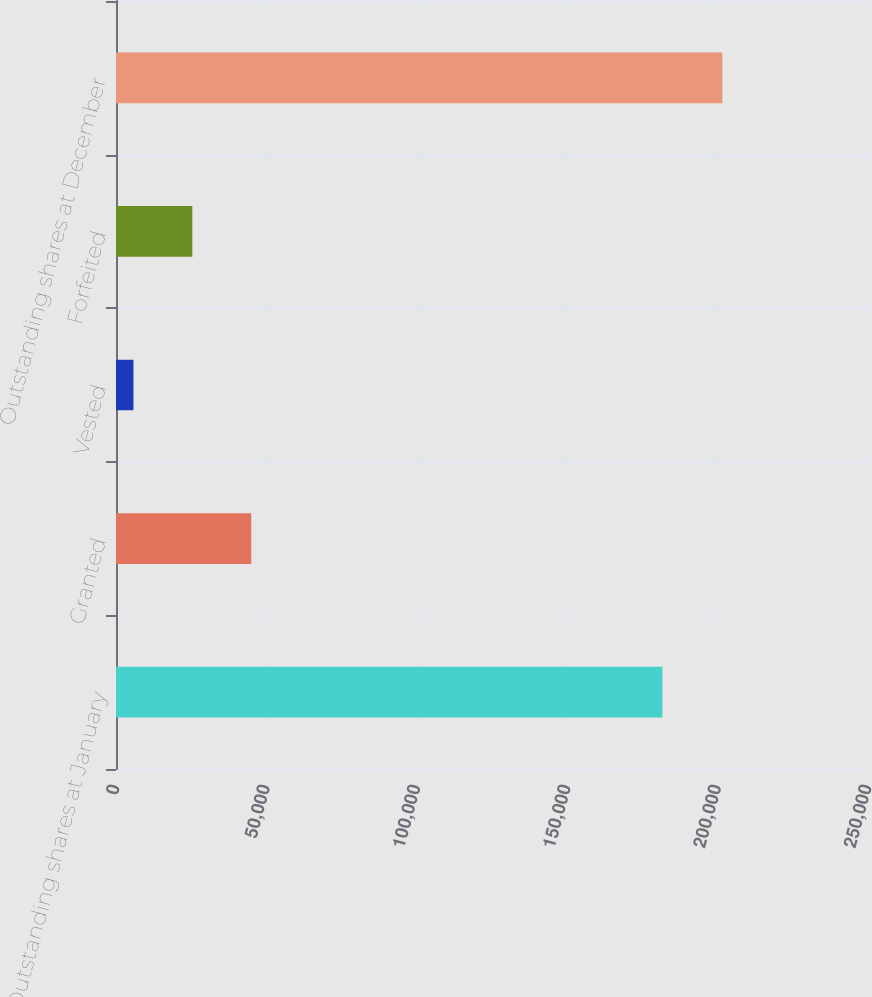Convert chart to OTSL. <chart><loc_0><loc_0><loc_500><loc_500><bar_chart><fcel>Outstanding shares at January<fcel>Granted<fcel>Vested<fcel>Forfeited<fcel>Outstanding shares at December<nl><fcel>181650<fcel>44954<fcel>5800<fcel>25377<fcel>201570<nl></chart> 